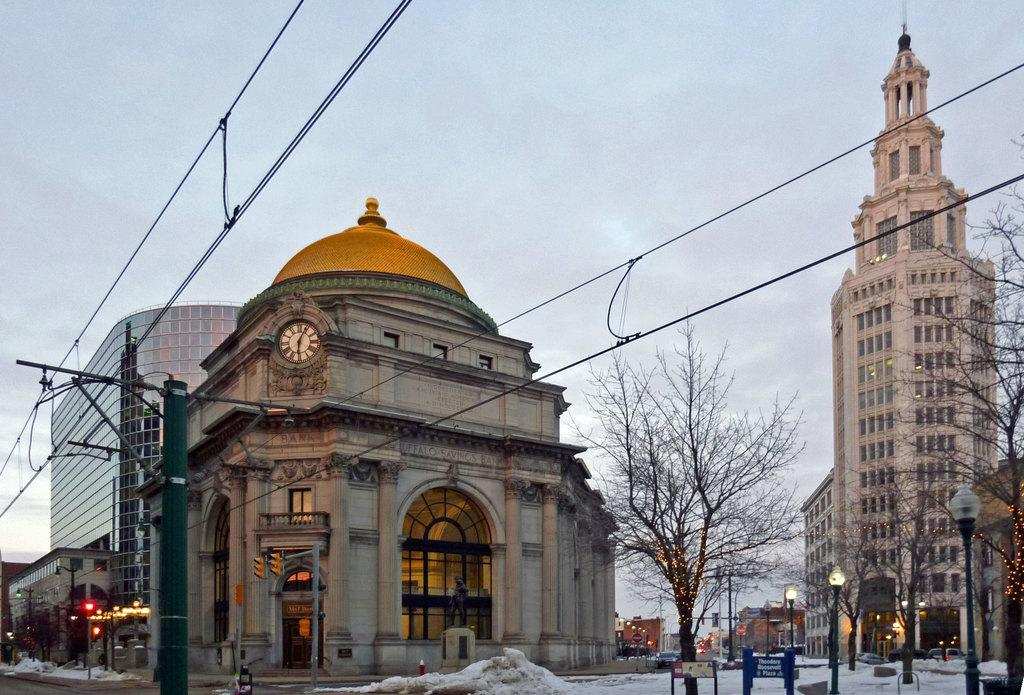What type of structures can be seen in the image? There are many buildings in the image. What other natural elements are present in the image? There are trees in the image. Are there any man-made objects besides buildings? Yes, there are poles and wires in the image. How would you describe the weather in the image? The sky is full of clouds, and the land is covered with snow. What type of wool is being used to create the clouds in the image? There is no wool present in the image; the clouds are natural formations in the sky. Can you explain the rule for flying in the image? There is no rule for flying in the image, as it is a still photograph and does not depict any movement or activity. 